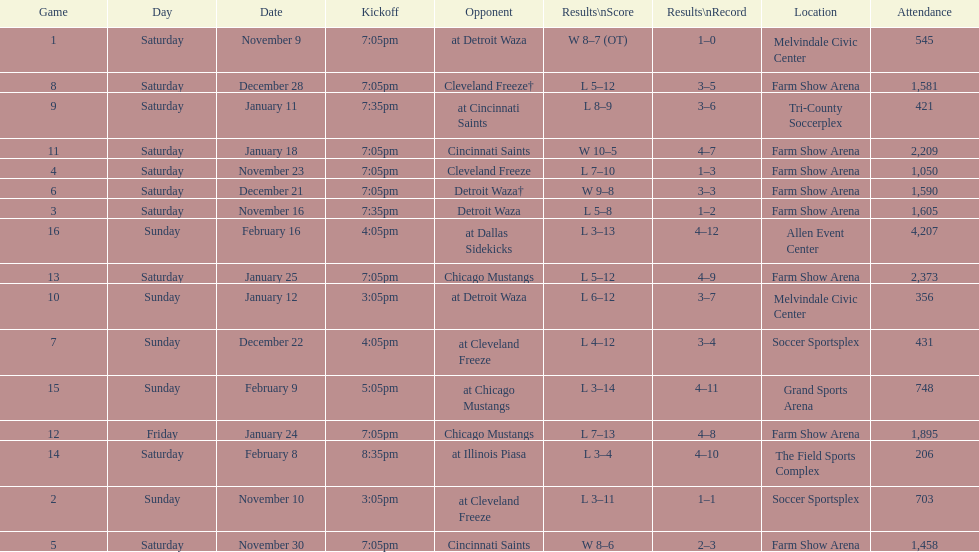How long was the teams longest losing streak? 5 games. 